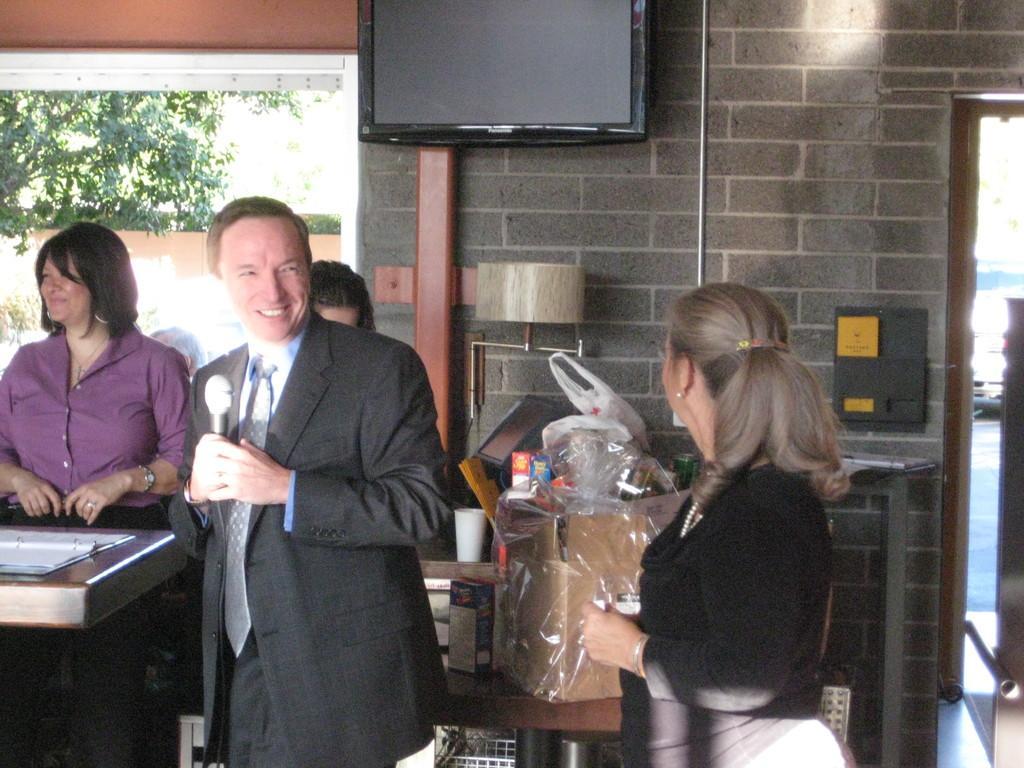Could you give a brief overview of what you see in this image? In this image we can see people. There are many objects placed on the table. There are few objects on the wall. There is television on the wall. There is a car in the image. A person is holding a microphone in the image. 